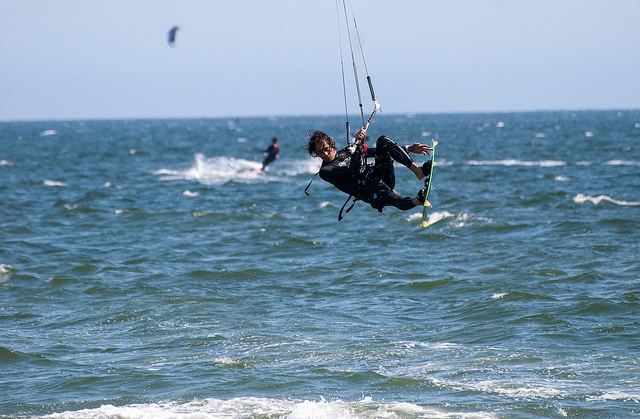Describe the objects in this image and their specific colors. I can see people in lavender, black, gray, and maroon tones, surfboard in lavender, black, gray, and teal tones, people in lavender, black, navy, gray, and blue tones, kite in lavender, gray, and darkgray tones, and surfboard in lavender, darkgray, and pink tones in this image. 